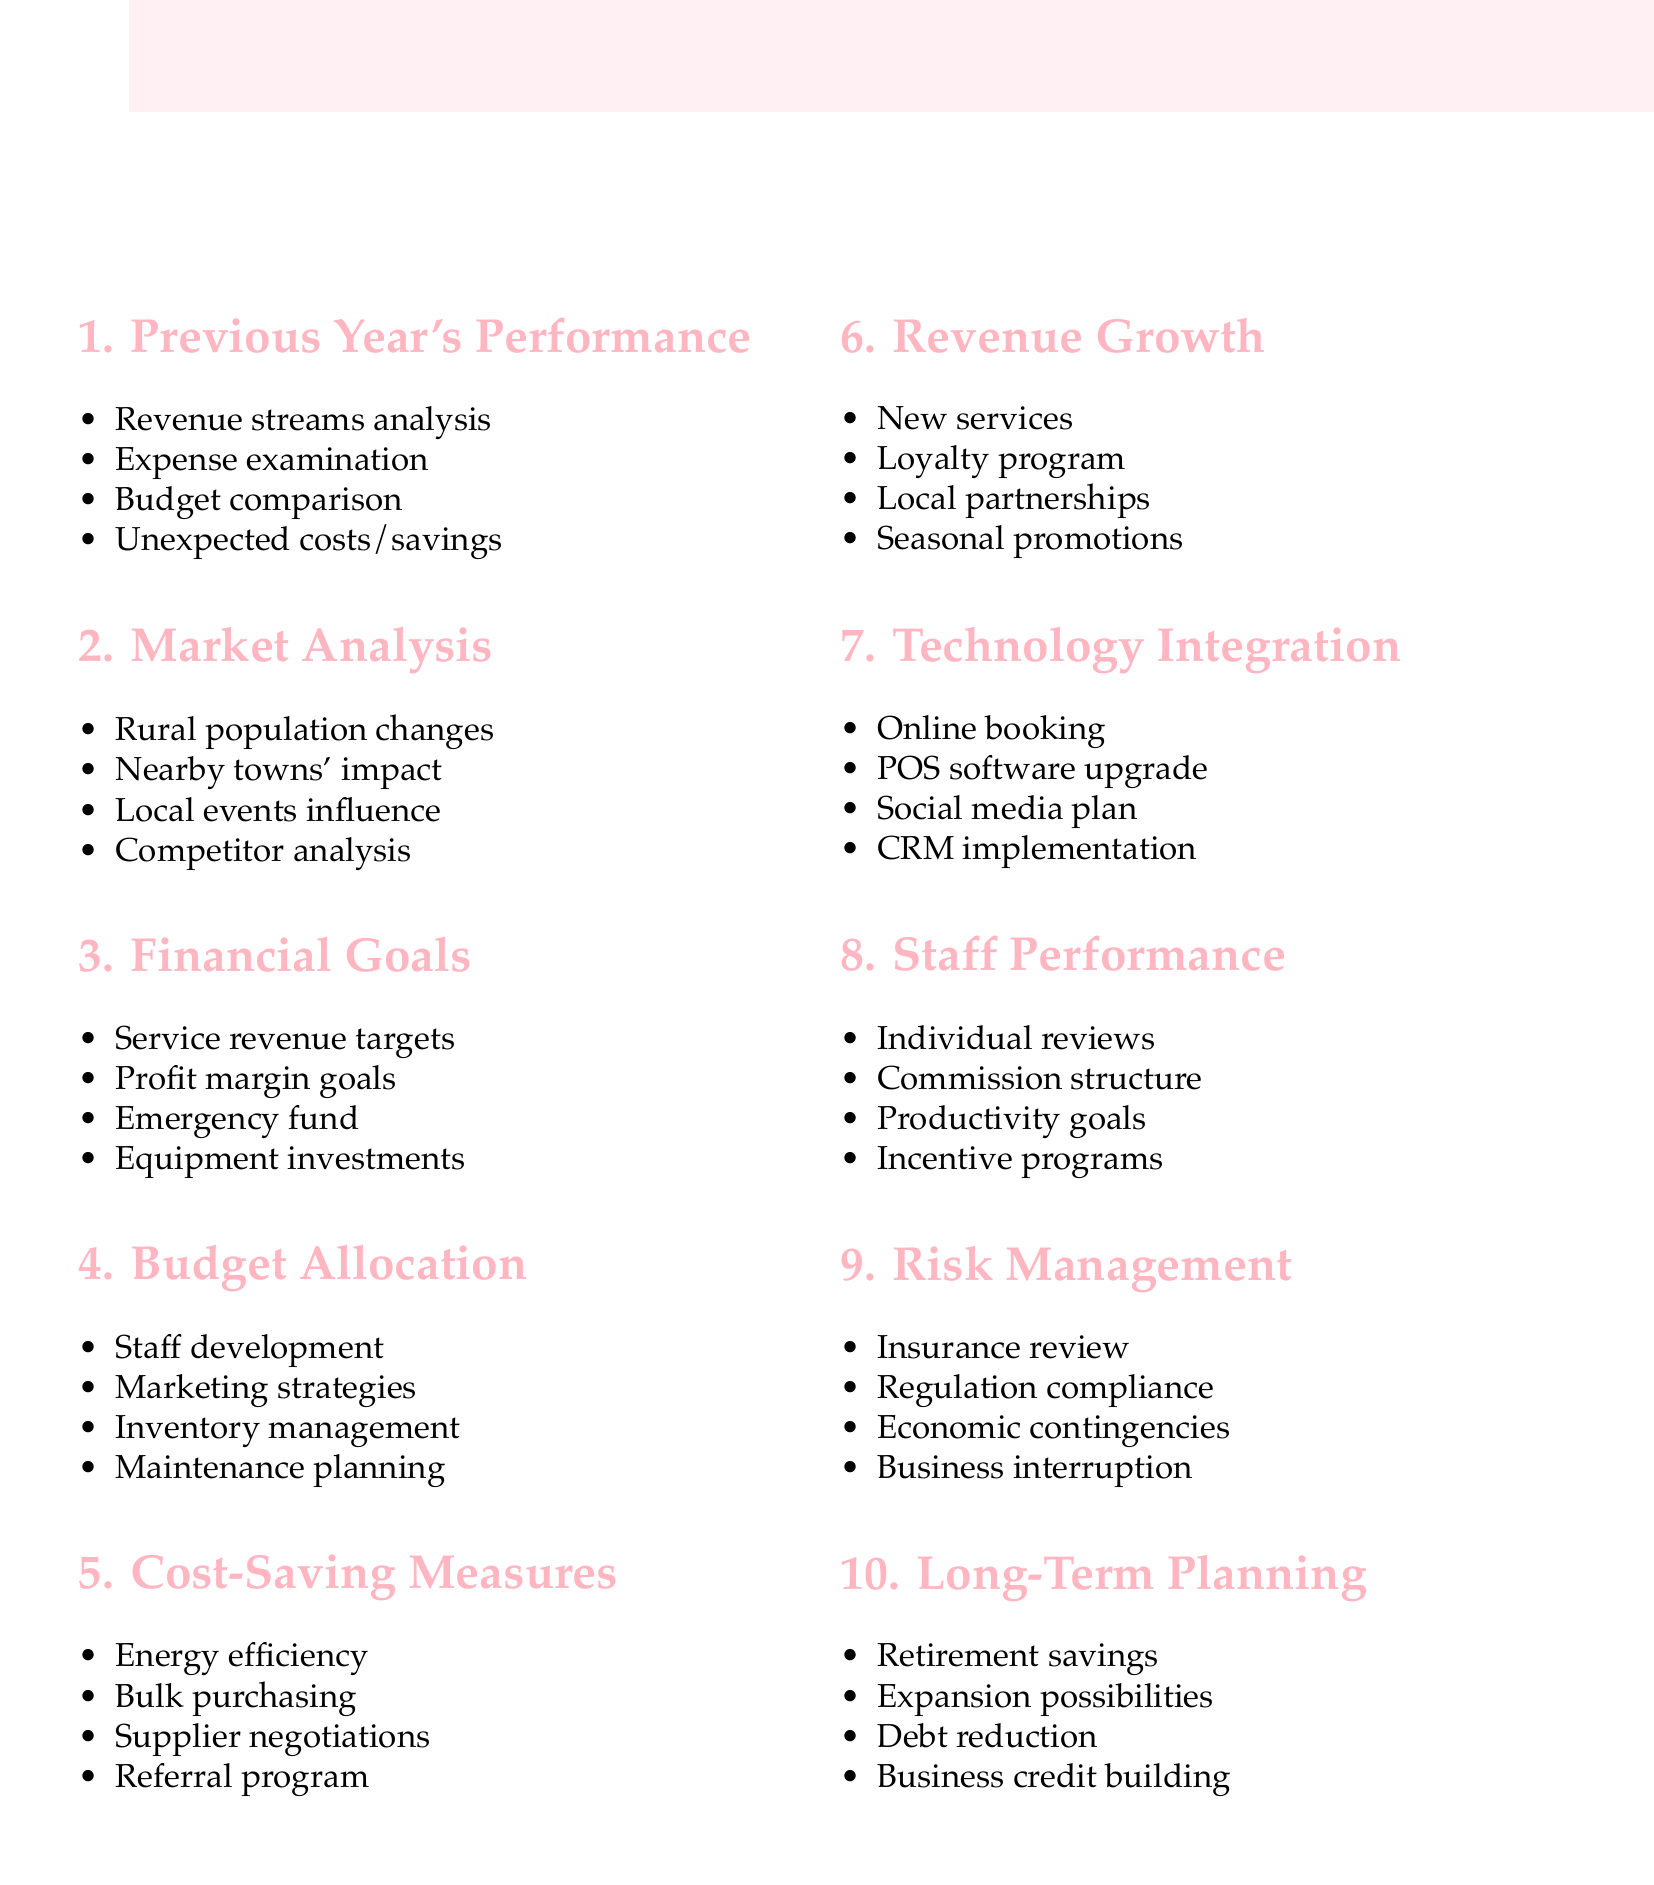What was analyzed in the financial performance review? The financial performance review included an analysis of revenue streams, expenses, budget comparisons, and unexpected costs or savings.
Answer: Revenue streams, expenses, budget comparisons, unexpected costs/savings What are the key local economic factors? The key local economic factors include population changes, the impact of nearby towns, local events, and competitor analysis.
Answer: Population changes, nearby towns, local events, competitor analysis What are the revenue targets for the upcoming year? The revenue targets for the upcoming year refer to the specific financial goals set for different services provided by the salon.
Answer: Revenue targets for different services What is one of the cost-saving measures proposed? One of the cost-saving measures proposed is to negotiate better rates with suppliers to reduce expenses.
Answer: Negotiating better rates with suppliers What is included in the long-term financial planning? The long-term financial planning includes retirement savings, expansion possibilities, debt reduction strategies, and business credit building.
Answer: Retirement savings, expansion possibilities, debt reduction, business credit building What type of promotion is suggested for revenue growth? Seasonal promotions are suggested as a strategy for revenue growth to attract clients at certain times of the year.
Answer: Seasonal promotions What technology is proposed for integration? The proposed technology integration includes implementing an online booking system to streamline appointment scheduling for clients.
Answer: Online booking system What is the focus of the staff performance review? The focus of the staff performance review is on assessing individual stylist performance and setting productivity goals.
Answer: Individual stylist performance What should be reviewed regarding risk management? The risk management aspect that should be reviewed includes insurance coverage to ensure adequate protection for the salon.
Answer: Insurance coverage review What is an emergency fund allocation related to? The emergency fund allocation is related to setting aside money for unforeseen circumstances that may affect the salon’s finances.
Answer: Emergency fund allocation 